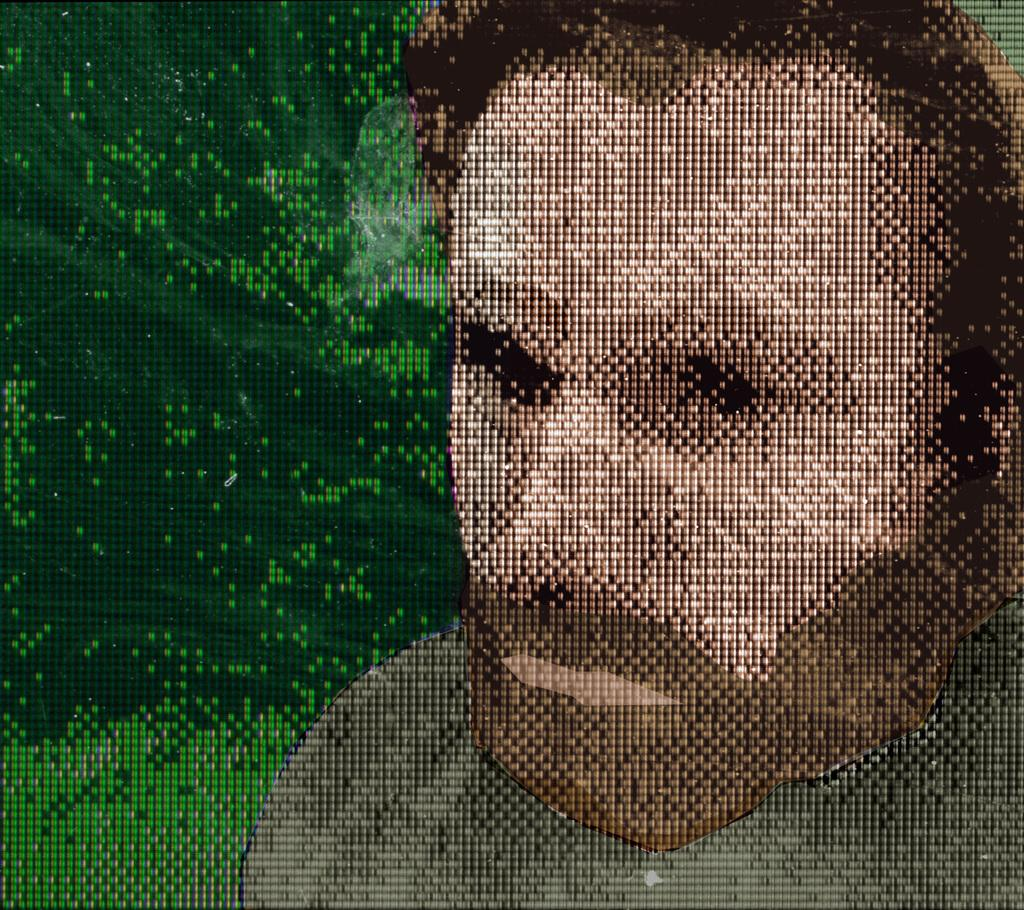What is the main subject of the image? There is a person depicted in the image. What color is the background of the image? The background of the image is green. What type of straw is being used to protest in the image? There is no straw or protest present in the image; it only features a person with a green background. 